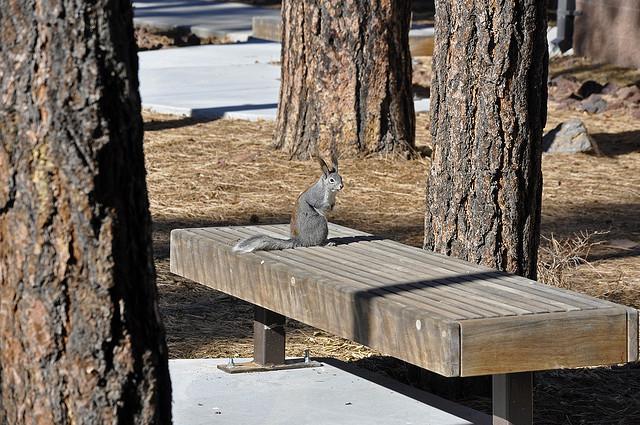What is the bench mounted on?
Write a very short answer. Cement. What is the squirrel looking for?
Be succinct. Nuts. Is the squirrel running?
Answer briefly. No. 